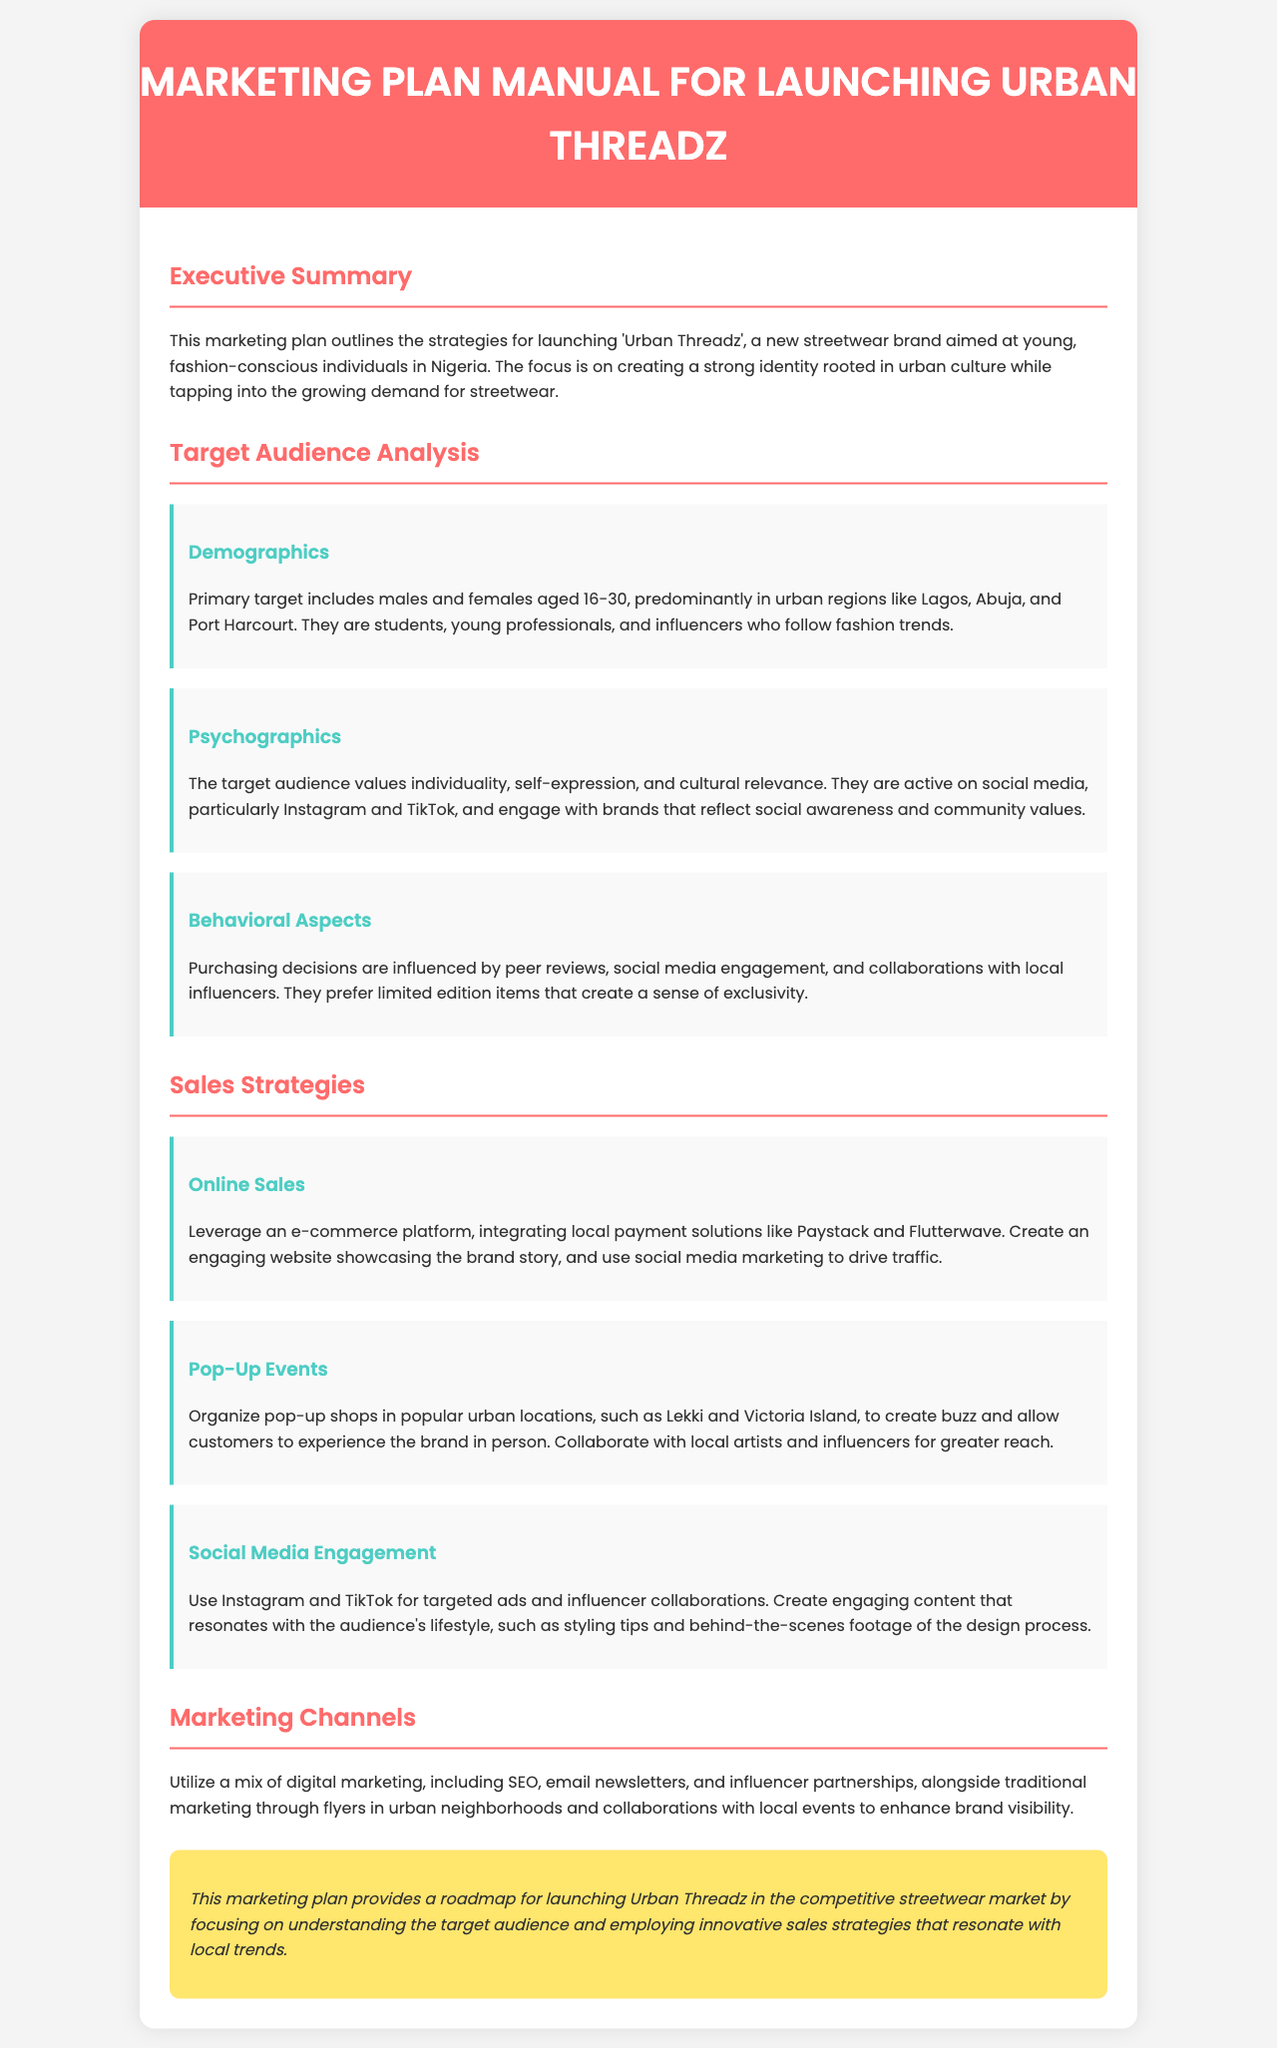what is the target age range for the primary audience? The primary target age range is specified as individuals who are aged 16-30.
Answer: 16-30 which social media platforms are emphasized for engagement? The document highlights Instagram and TikTok as key platforms for audience engagement.
Answer: Instagram and TikTok what is the main objective of the marketing plan? The overall aim of the marketing plan is to launch 'Urban Threadz', capturing the interest of young, fashion-conscious individuals in Nigeria.
Answer: Launch 'Urban Threadz' name one location where pop-up shops will be organized. The document mentions Lekki as one of the urban locations for pop-up shops.
Answer: Lekki what is one method of payment mentioned for e-commerce? The document mentions local payment solutions like Paystack for online sales.
Answer: Paystack which segment of the audience values individuality and self-expression? The target audience that values these traits includes young, fashion-conscious individuals.
Answer: Young, fashion-conscious individuals how does the plan propose to enhance brand visibility? The plan suggests utilizing traditional marketing through flyers in urban neighborhoods for enhancing visibility.
Answer: Flyers in urban neighborhoods what color is used in the header of the document? The header color of the document is specified as FF6B6B, described in the context as a red shade.
Answer: FF6B6B name a sales strategy mentioned in the document. One sales strategy outlined is organizing pop-up events to engage the audience directly.
Answer: Pop-Up Events 